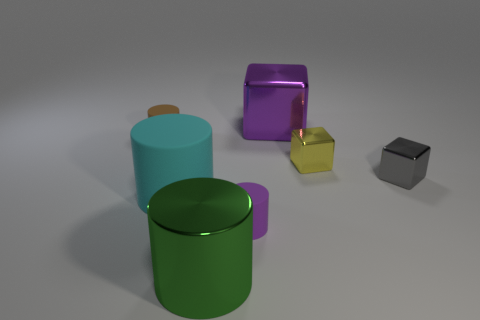What is the color of the tiny cylinder that is made of the same material as the small brown thing?
Make the answer very short. Purple. Are there fewer tiny metallic things than small yellow metallic things?
Make the answer very short. No. What is the small object that is behind the small gray block and to the right of the big green metallic cylinder made of?
Offer a very short reply. Metal. Is there a green object that is behind the big object on the right side of the small purple cylinder?
Provide a short and direct response. No. How many shiny cubes are the same color as the big matte thing?
Give a very brief answer. 0. Do the gray thing and the large green thing have the same material?
Your answer should be very brief. Yes. Are there any tiny gray things in front of the purple cylinder?
Ensure brevity in your answer.  No. What is the purple thing behind the tiny metallic cube in front of the yellow metal object made of?
Make the answer very short. Metal. What is the size of the gray thing that is the same shape as the yellow metal thing?
Make the answer very short. Small. What is the color of the thing that is both in front of the cyan cylinder and on the right side of the green cylinder?
Ensure brevity in your answer.  Purple. 